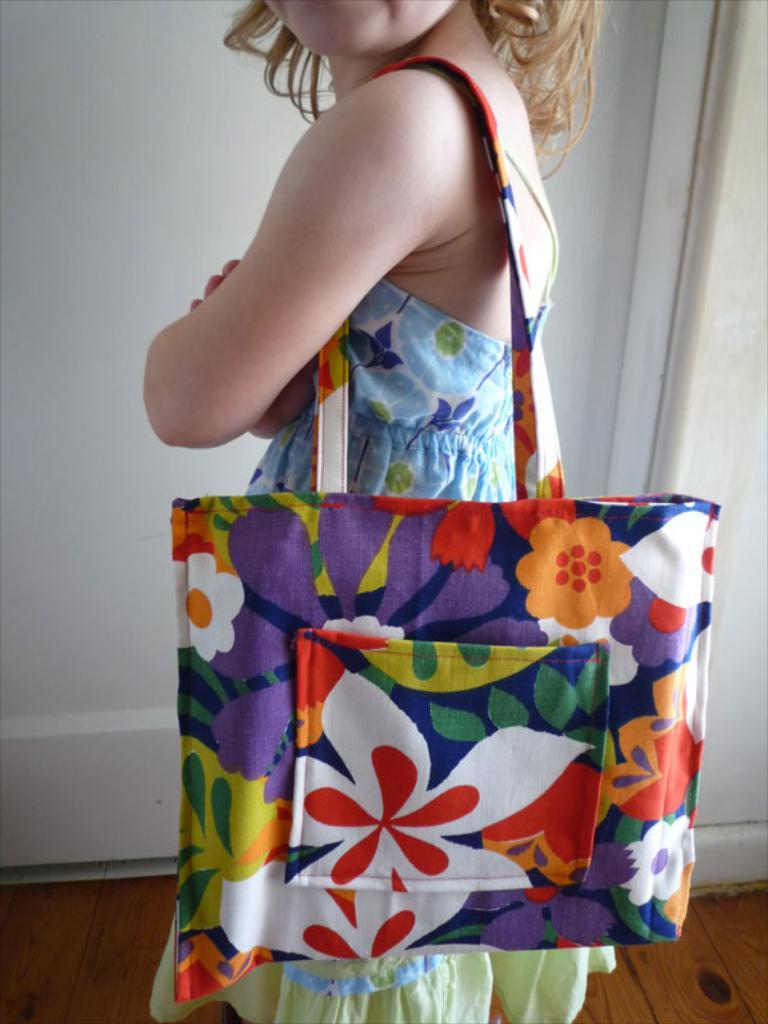What is the main subject of the image? There is a person in the image. What is the person doing in the image? The person is standing. What is the person holding in the image? The person is holding a bag. What can be seen behind the person in the image? There is a wall behind the person. Where is the lunchroom located in the image? There is no lunchroom present in the image. What is the person's interest in the image? The provided facts do not give any information about the person's interests. 